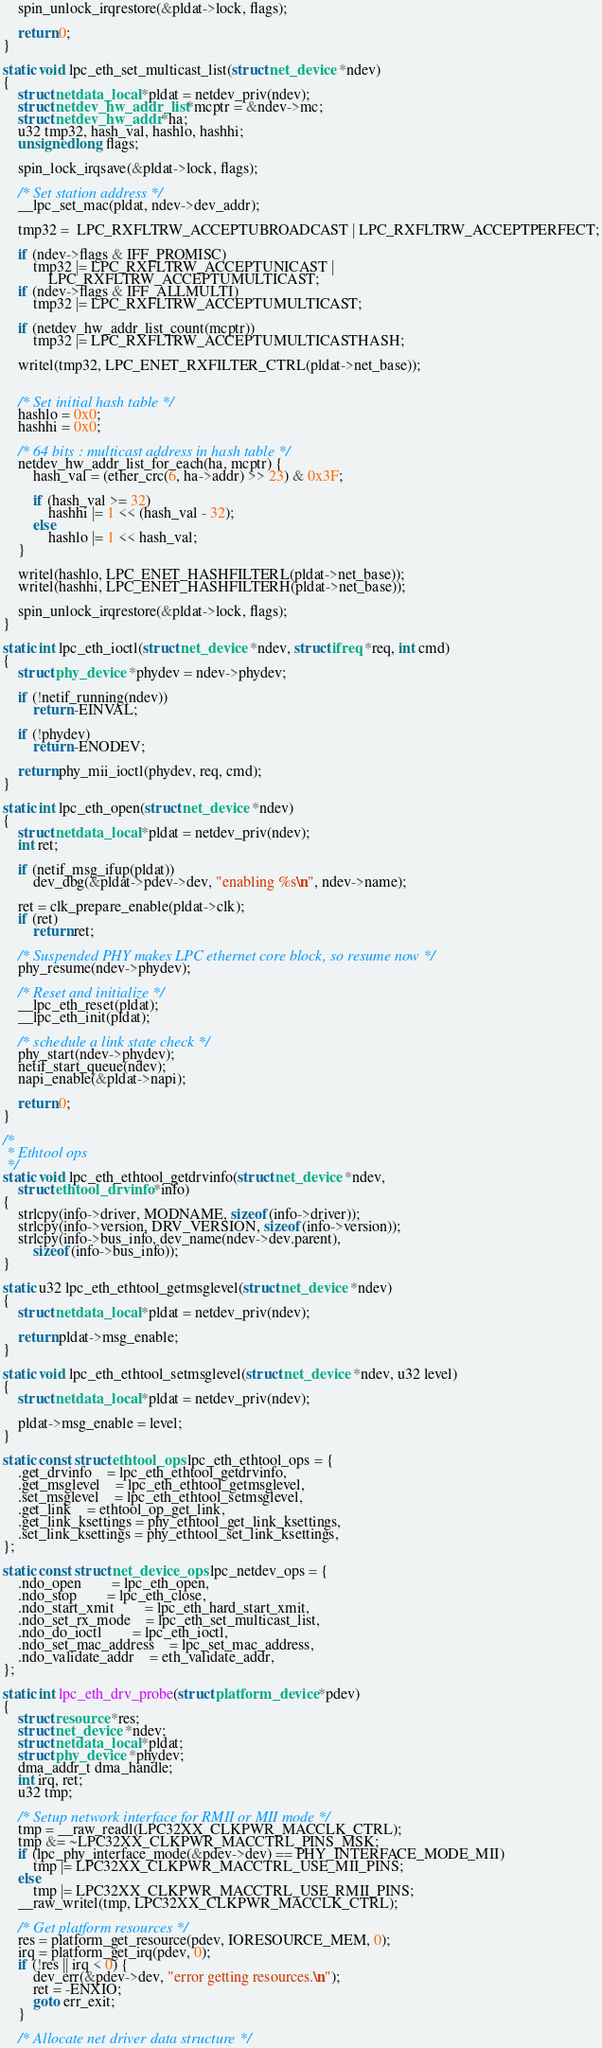Convert code to text. <code><loc_0><loc_0><loc_500><loc_500><_C_>	spin_unlock_irqrestore(&pldat->lock, flags);

	return 0;
}

static void lpc_eth_set_multicast_list(struct net_device *ndev)
{
	struct netdata_local *pldat = netdev_priv(ndev);
	struct netdev_hw_addr_list *mcptr = &ndev->mc;
	struct netdev_hw_addr *ha;
	u32 tmp32, hash_val, hashlo, hashhi;
	unsigned long flags;

	spin_lock_irqsave(&pldat->lock, flags);

	/* Set station address */
	__lpc_set_mac(pldat, ndev->dev_addr);

	tmp32 =  LPC_RXFLTRW_ACCEPTUBROADCAST | LPC_RXFLTRW_ACCEPTPERFECT;

	if (ndev->flags & IFF_PROMISC)
		tmp32 |= LPC_RXFLTRW_ACCEPTUNICAST |
			LPC_RXFLTRW_ACCEPTUMULTICAST;
	if (ndev->flags & IFF_ALLMULTI)
		tmp32 |= LPC_RXFLTRW_ACCEPTUMULTICAST;

	if (netdev_hw_addr_list_count(mcptr))
		tmp32 |= LPC_RXFLTRW_ACCEPTUMULTICASTHASH;

	writel(tmp32, LPC_ENET_RXFILTER_CTRL(pldat->net_base));


	/* Set initial hash table */
	hashlo = 0x0;
	hashhi = 0x0;

	/* 64 bits : multicast address in hash table */
	netdev_hw_addr_list_for_each(ha, mcptr) {
		hash_val = (ether_crc(6, ha->addr) >> 23) & 0x3F;

		if (hash_val >= 32)
			hashhi |= 1 << (hash_val - 32);
		else
			hashlo |= 1 << hash_val;
	}

	writel(hashlo, LPC_ENET_HASHFILTERL(pldat->net_base));
	writel(hashhi, LPC_ENET_HASHFILTERH(pldat->net_base));

	spin_unlock_irqrestore(&pldat->lock, flags);
}

static int lpc_eth_ioctl(struct net_device *ndev, struct ifreq *req, int cmd)
{
	struct phy_device *phydev = ndev->phydev;

	if (!netif_running(ndev))
		return -EINVAL;

	if (!phydev)
		return -ENODEV;

	return phy_mii_ioctl(phydev, req, cmd);
}

static int lpc_eth_open(struct net_device *ndev)
{
	struct netdata_local *pldat = netdev_priv(ndev);
	int ret;

	if (netif_msg_ifup(pldat))
		dev_dbg(&pldat->pdev->dev, "enabling %s\n", ndev->name);

	ret = clk_prepare_enable(pldat->clk);
	if (ret)
		return ret;

	/* Suspended PHY makes LPC ethernet core block, so resume now */
	phy_resume(ndev->phydev);

	/* Reset and initialize */
	__lpc_eth_reset(pldat);
	__lpc_eth_init(pldat);

	/* schedule a link state check */
	phy_start(ndev->phydev);
	netif_start_queue(ndev);
	napi_enable(&pldat->napi);

	return 0;
}

/*
 * Ethtool ops
 */
static void lpc_eth_ethtool_getdrvinfo(struct net_device *ndev,
	struct ethtool_drvinfo *info)
{
	strlcpy(info->driver, MODNAME, sizeof(info->driver));
	strlcpy(info->version, DRV_VERSION, sizeof(info->version));
	strlcpy(info->bus_info, dev_name(ndev->dev.parent),
		sizeof(info->bus_info));
}

static u32 lpc_eth_ethtool_getmsglevel(struct net_device *ndev)
{
	struct netdata_local *pldat = netdev_priv(ndev);

	return pldat->msg_enable;
}

static void lpc_eth_ethtool_setmsglevel(struct net_device *ndev, u32 level)
{
	struct netdata_local *pldat = netdev_priv(ndev);

	pldat->msg_enable = level;
}

static const struct ethtool_ops lpc_eth_ethtool_ops = {
	.get_drvinfo	= lpc_eth_ethtool_getdrvinfo,
	.get_msglevel	= lpc_eth_ethtool_getmsglevel,
	.set_msglevel	= lpc_eth_ethtool_setmsglevel,
	.get_link	= ethtool_op_get_link,
	.get_link_ksettings = phy_ethtool_get_link_ksettings,
	.set_link_ksettings = phy_ethtool_set_link_ksettings,
};

static const struct net_device_ops lpc_netdev_ops = {
	.ndo_open		= lpc_eth_open,
	.ndo_stop		= lpc_eth_close,
	.ndo_start_xmit		= lpc_eth_hard_start_xmit,
	.ndo_set_rx_mode	= lpc_eth_set_multicast_list,
	.ndo_do_ioctl		= lpc_eth_ioctl,
	.ndo_set_mac_address	= lpc_set_mac_address,
	.ndo_validate_addr	= eth_validate_addr,
};

static int lpc_eth_drv_probe(struct platform_device *pdev)
{
	struct resource *res;
	struct net_device *ndev;
	struct netdata_local *pldat;
	struct phy_device *phydev;
	dma_addr_t dma_handle;
	int irq, ret;
	u32 tmp;

	/* Setup network interface for RMII or MII mode */
	tmp = __raw_readl(LPC32XX_CLKPWR_MACCLK_CTRL);
	tmp &= ~LPC32XX_CLKPWR_MACCTRL_PINS_MSK;
	if (lpc_phy_interface_mode(&pdev->dev) == PHY_INTERFACE_MODE_MII)
		tmp |= LPC32XX_CLKPWR_MACCTRL_USE_MII_PINS;
	else
		tmp |= LPC32XX_CLKPWR_MACCTRL_USE_RMII_PINS;
	__raw_writel(tmp, LPC32XX_CLKPWR_MACCLK_CTRL);

	/* Get platform resources */
	res = platform_get_resource(pdev, IORESOURCE_MEM, 0);
	irq = platform_get_irq(pdev, 0);
	if (!res || irq < 0) {
		dev_err(&pdev->dev, "error getting resources.\n");
		ret = -ENXIO;
		goto err_exit;
	}

	/* Allocate net driver data structure */</code> 